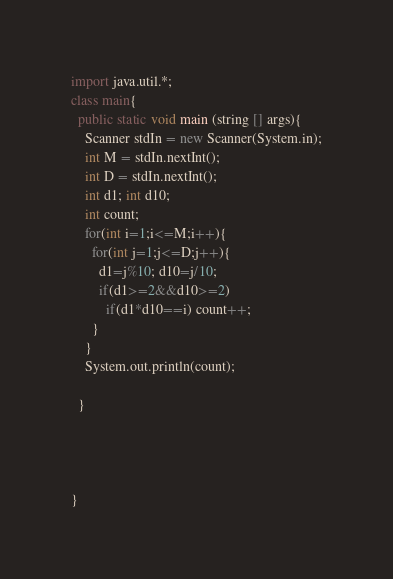<code> <loc_0><loc_0><loc_500><loc_500><_Java_>import java.util.*;
class main{
  public static void main (string [] args){
    Scanner stdIn = new Scanner(System.in);
    int M = stdIn.nextInt();
    int D = stdIn.nextInt();
    int d1; int d10;
    int count;
    for(int i=1;i<=M;i++){
      for(int j=1;j<=D;j++){
        d1=j%10; d10=j/10;
        if(d1>=2&&d10>=2) 
          if(d1*d10==i) count++;
      }
    }
    System.out.println(count);
    
  }
  
  
  
  
}</code> 